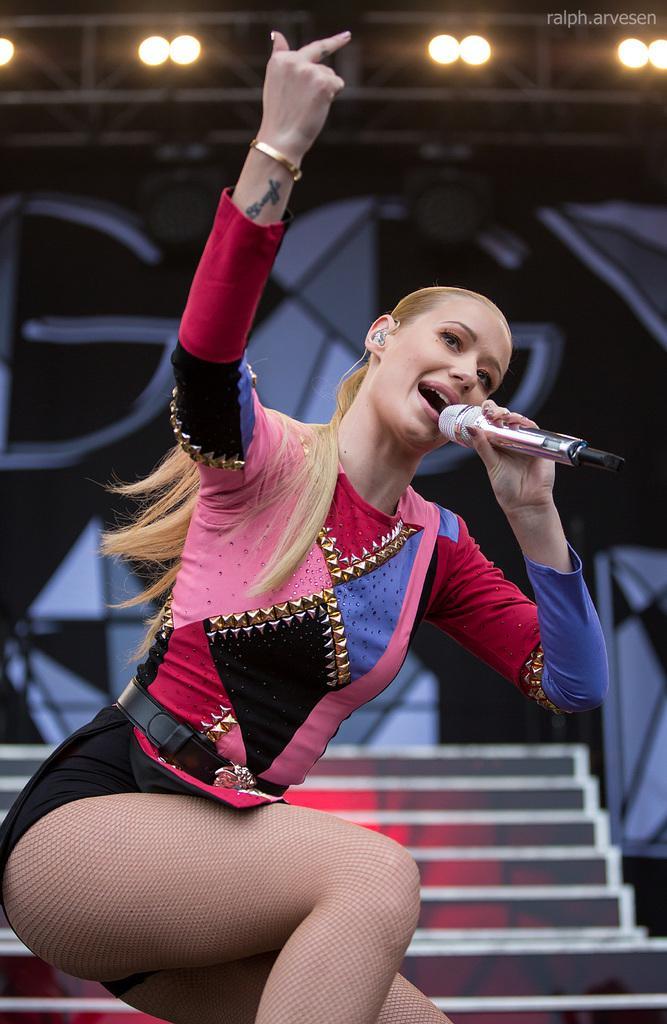In one or two sentences, can you explain what this image depicts? In this image I can see a woman wearing pink, black, red and blue colored dress is holding a microphone in her hand. In the background I can see a huge banner and few lights to the metal rods. 